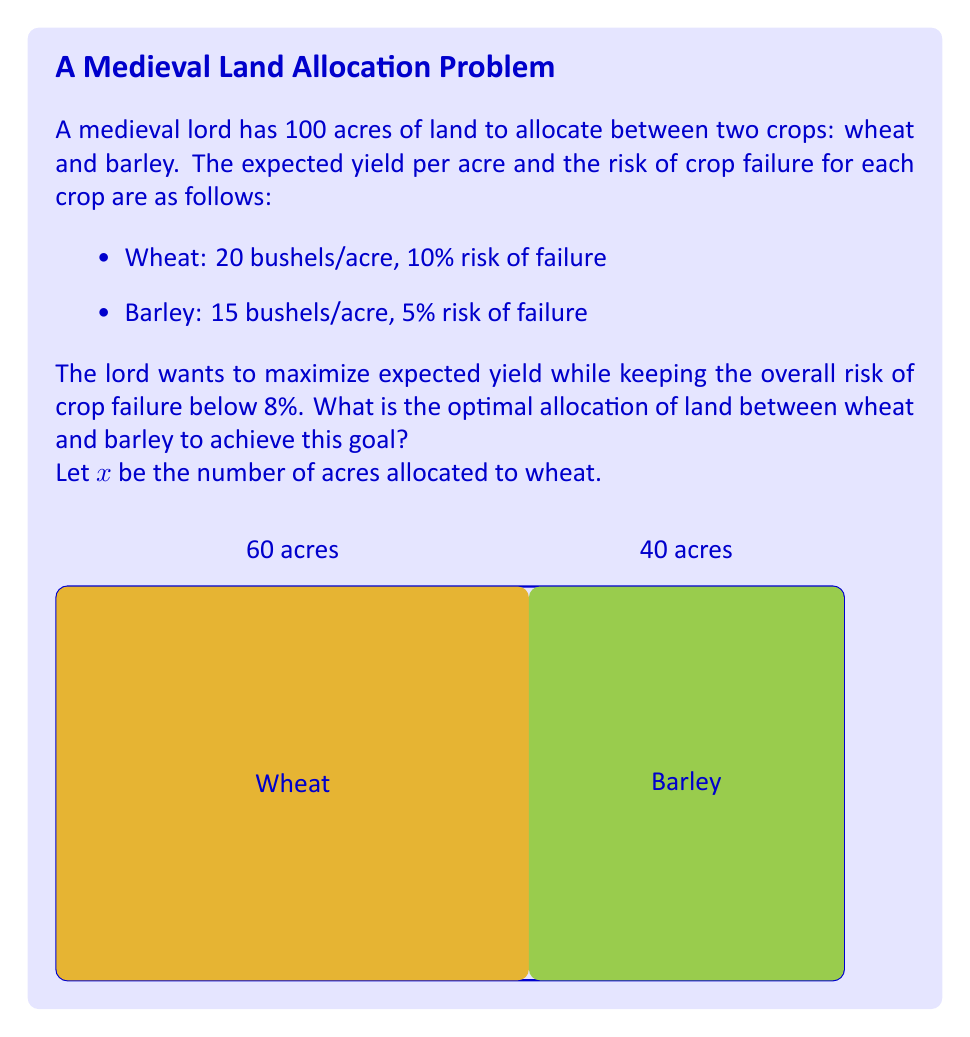What is the answer to this math problem? Let's approach this step-by-step:

1) First, let's define our variables:
   $x$ = acres of wheat
   $100 - x$ = acres of barley

2) The expected yield function is:
   $Y = 20x + 15(100-x)$

3) The risk function is:
   $R = \frac{10x + 5(100-x)}{100} = \frac{5x + 500}{100}$

4) We want to maximize $Y$ subject to the constraint $R \leq 8$

5) From the risk constraint:
   $\frac{5x + 500}{100} \leq 8$
   $5x + 500 \leq 800$
   $5x \leq 300$
   $x \leq 60$

6) Now, let's look at the yield function:
   $Y = 20x + 15(100-x) = 20x + 1500 - 15x = 5x + 1500$

7) This is a linear function, increasing with $x$. Therefore, to maximize yield while satisfying the risk constraint, we should use the maximum allowable $x$, which is 60.

8) So the optimal allocation is:
   60 acres of wheat
   40 acres of barley

9) We can verify:
   Expected yield = $20 * 60 + 15 * 40 = 1800$ bushels
   Risk = $\frac{10 * 60 + 5 * 40}{100} = 8\%$
Answer: 60 acres wheat, 40 acres barley 